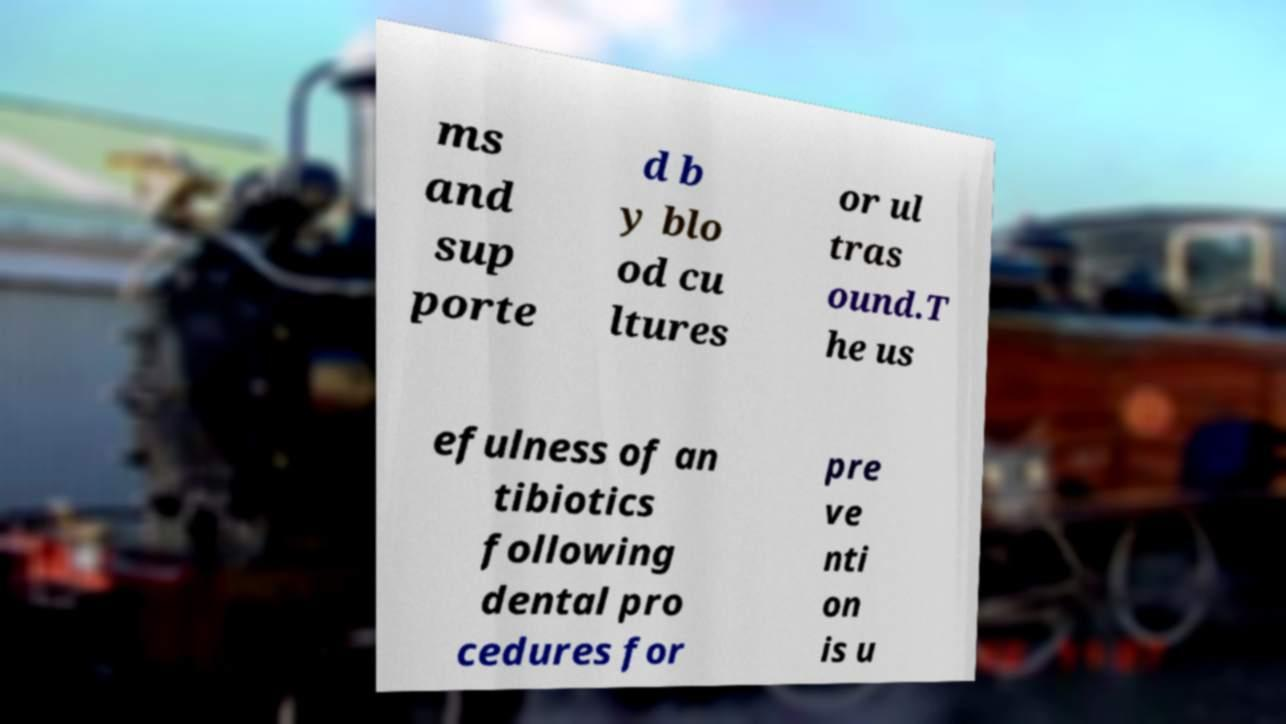Please read and relay the text visible in this image. What does it say? ms and sup porte d b y blo od cu ltures or ul tras ound.T he us efulness of an tibiotics following dental pro cedures for pre ve nti on is u 